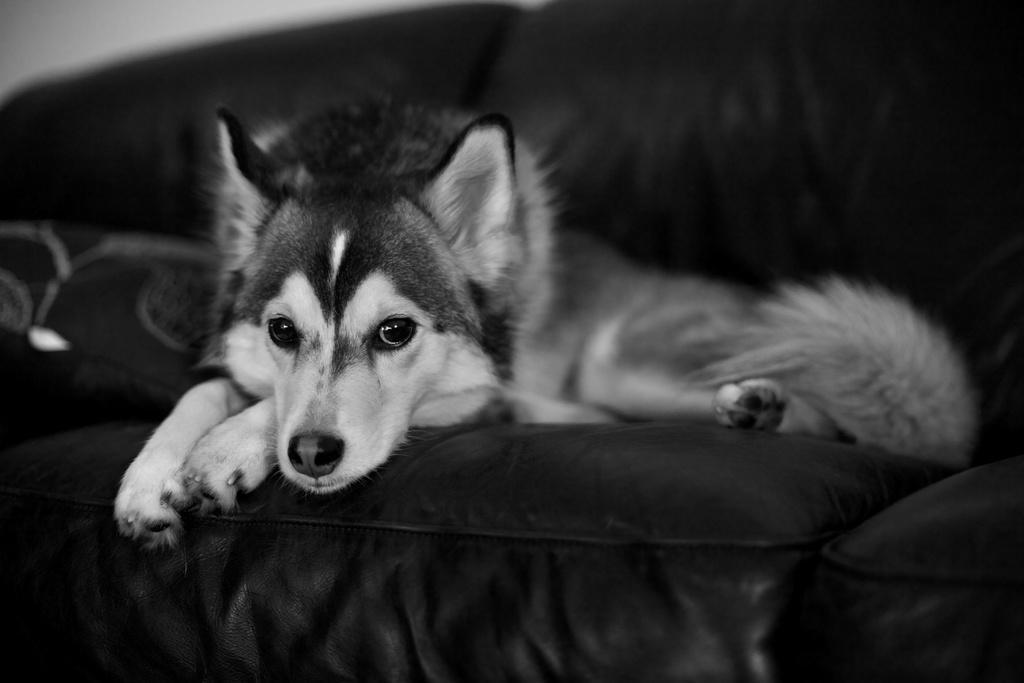Describe this image in one or two sentences. In this picture I can see a dog which is on a couch. I see that this is a white and black color picture. 